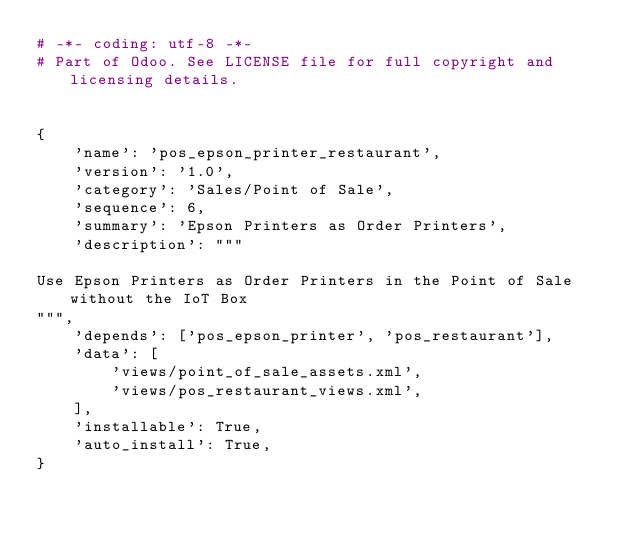Convert code to text. <code><loc_0><loc_0><loc_500><loc_500><_Python_># -*- coding: utf-8 -*-
# Part of Odoo. See LICENSE file for full copyright and licensing details.


{
    'name': 'pos_epson_printer_restaurant',
    'version': '1.0',
    'category': 'Sales/Point of Sale',
    'sequence': 6,
    'summary': 'Epson Printers as Order Printers',
    'description': """

Use Epson Printers as Order Printers in the Point of Sale without the IoT Box
""",
    'depends': ['pos_epson_printer', 'pos_restaurant'],
    'data': [
        'views/point_of_sale_assets.xml',
        'views/pos_restaurant_views.xml',
    ],
    'installable': True,
    'auto_install': True,
}
</code> 